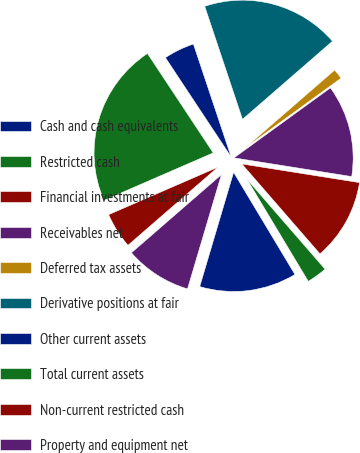Convert chart. <chart><loc_0><loc_0><loc_500><loc_500><pie_chart><fcel>Cash and cash equivalents<fcel>Restricted cash<fcel>Financial investments at fair<fcel>Receivables net<fcel>Deferred tax assets<fcel>Derivative positions at fair<fcel>Other current assets<fcel>Total current assets<fcel>Non-current restricted cash<fcel>Property and equipment net<nl><fcel>13.19%<fcel>2.78%<fcel>11.11%<fcel>12.5%<fcel>1.39%<fcel>18.75%<fcel>4.17%<fcel>22.22%<fcel>4.86%<fcel>9.03%<nl></chart> 